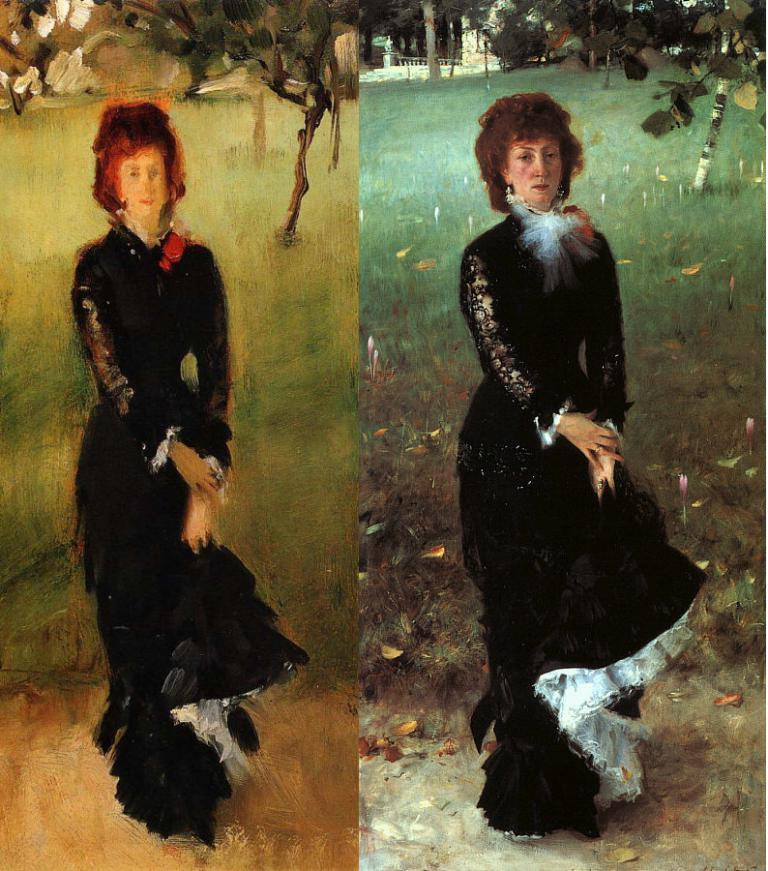What is depicted in the foreground of the image? There are paintings of a woman in the foreground of the image. What type of landscape can be seen in the background of the image? There is grassland and trees in the background of the image. What type of insurance is being advertised in the painting of the woman? There is no insurance being advertised in the painting of the woman, as the image only shows paintings of a woman and the background landscape. 